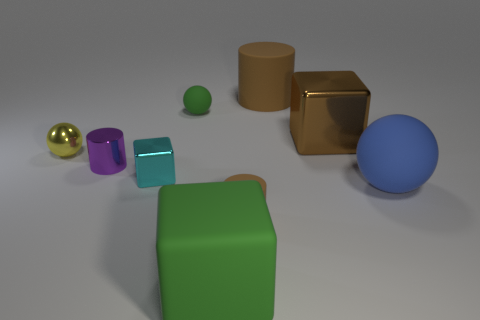How many other objects are there of the same size as the metal sphere?
Give a very brief answer. 4. There is a matte thing that is the same color as the large rubber cylinder; what is its size?
Provide a succinct answer. Small. There is a green thing in front of the cyan cube; is it the same shape as the large metallic thing?
Your answer should be compact. Yes. There is a big block that is behind the blue object; what is its material?
Provide a succinct answer. Metal. There is a tiny rubber object that is the same color as the big shiny thing; what shape is it?
Provide a succinct answer. Cylinder. Is there a large block made of the same material as the yellow thing?
Your answer should be compact. Yes. The purple cylinder is what size?
Keep it short and to the point. Small. What number of brown objects are large matte cylinders or big matte objects?
Your answer should be very brief. 1. How many big matte objects are the same shape as the big metallic thing?
Offer a terse response. 1. What number of metallic cubes have the same size as the blue sphere?
Your answer should be very brief. 1. 